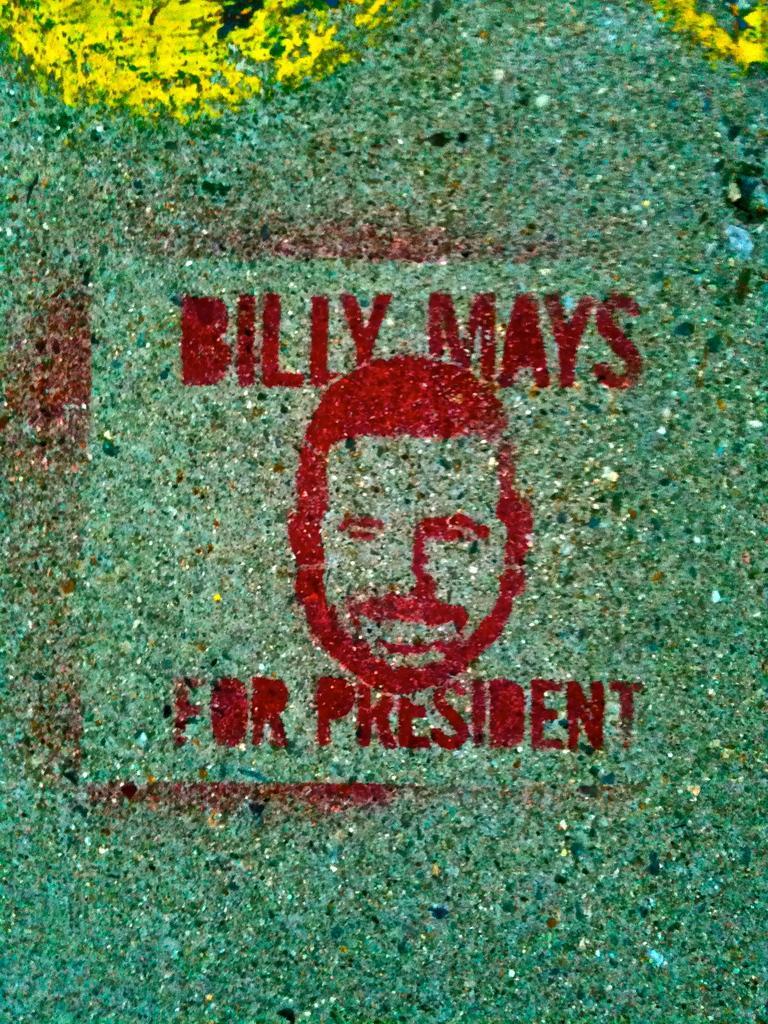How would you summarize this image in a sentence or two? In this image we can see some text and the painting of the face of a person on the surface. 